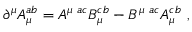Convert formula to latex. <formula><loc_0><loc_0><loc_500><loc_500>{ \partial } ^ { \mu } A _ { \mu } ^ { a b } = A ^ { \mu a c } B _ { \mu } ^ { c b } - B ^ { \mu a c } A _ { \mu } ^ { c b } ,</formula> 